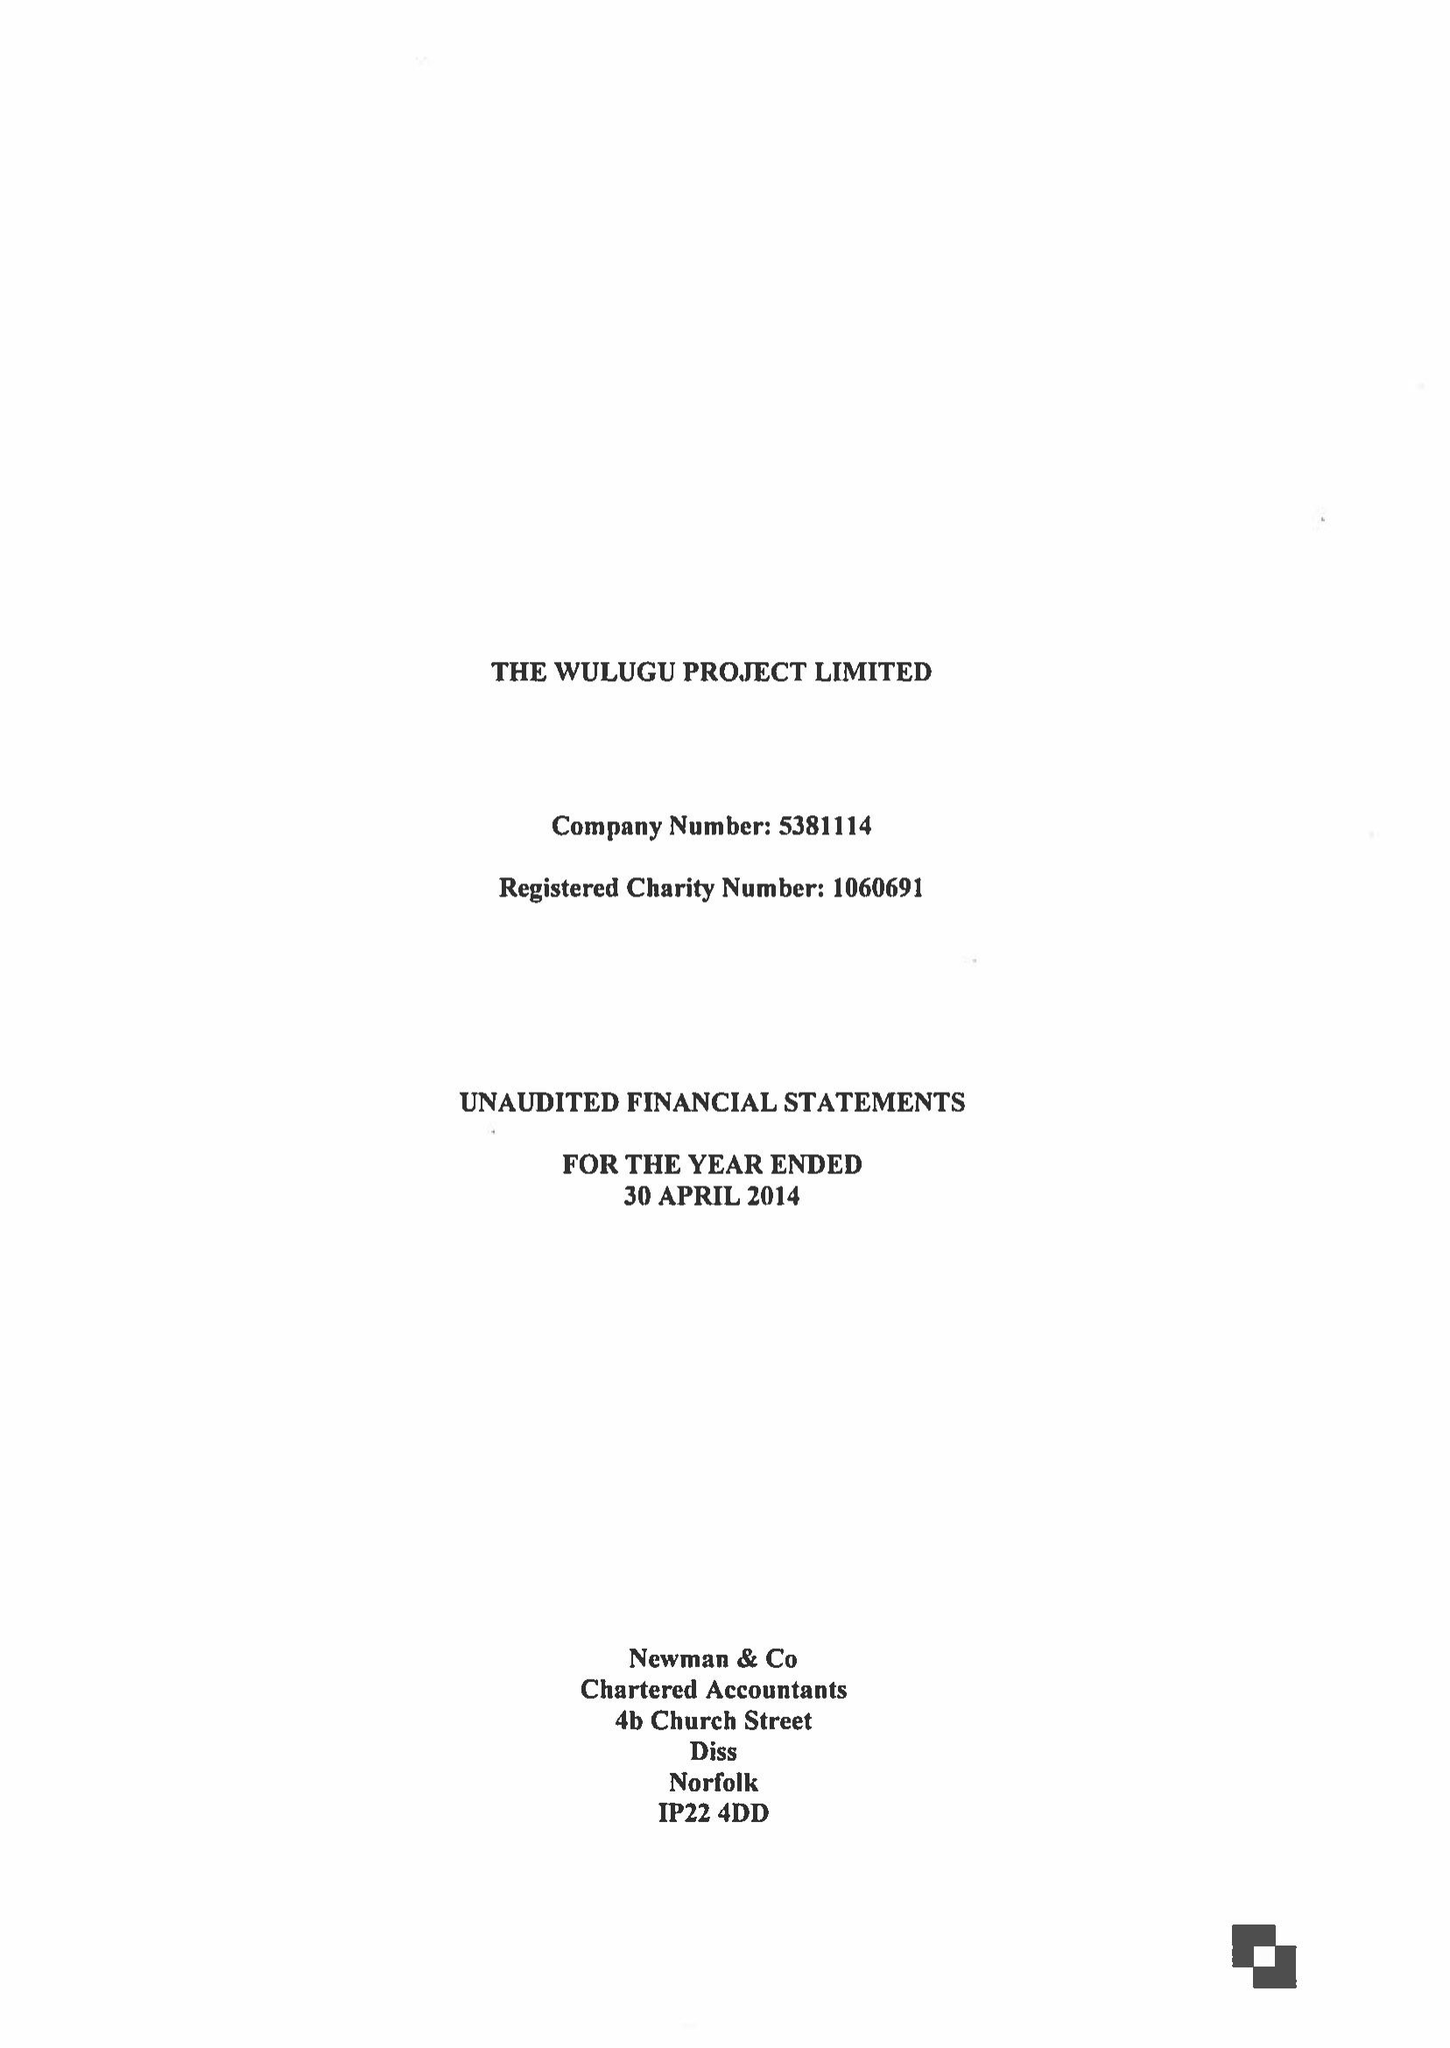What is the value for the income_annually_in_british_pounds?
Answer the question using a single word or phrase. 149478.00 